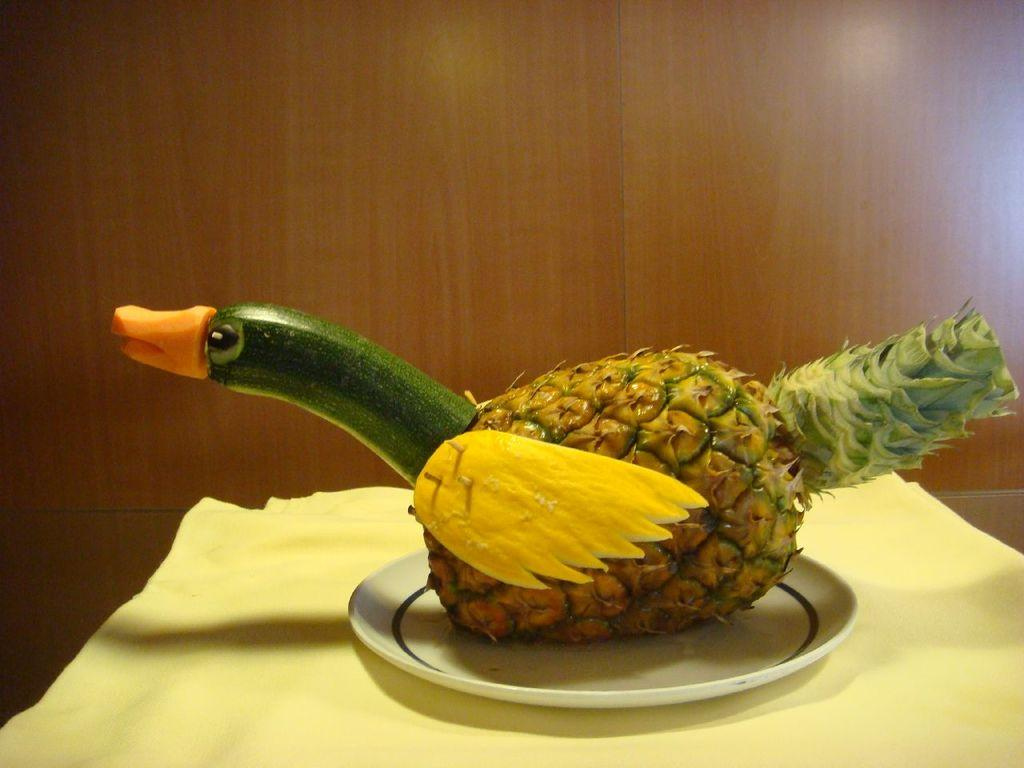What type of furniture is present in the image? There is a table in the image. What is covering the table? There is a cloth on the table. What is placed on top of the cloth? There is a plate on the cloth. What is depicted on the plate? There is carving in the plate. What can be seen in the background of the image? There is a wall in the background of the image. Can you see any feathers on the plate in the image? There are no feathers present on the plate in the image. Is the plate hot to the touch in the image? The plate's temperature is not mentioned in the image, so we cannot determine if it is hot or not. 